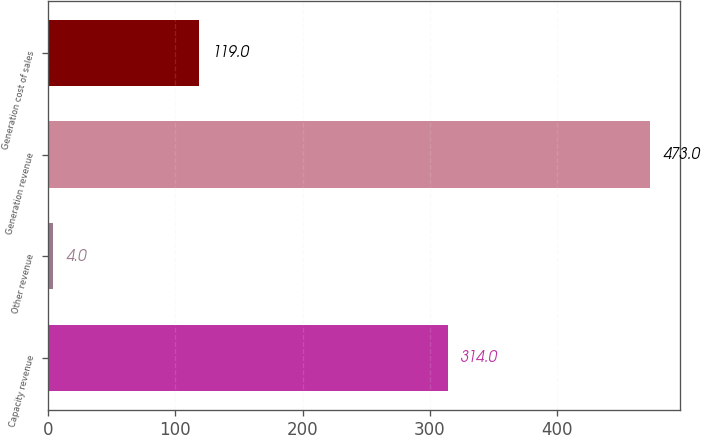Convert chart to OTSL. <chart><loc_0><loc_0><loc_500><loc_500><bar_chart><fcel>Capacity revenue<fcel>Other revenue<fcel>Generation revenue<fcel>Generation cost of sales<nl><fcel>314<fcel>4<fcel>473<fcel>119<nl></chart> 